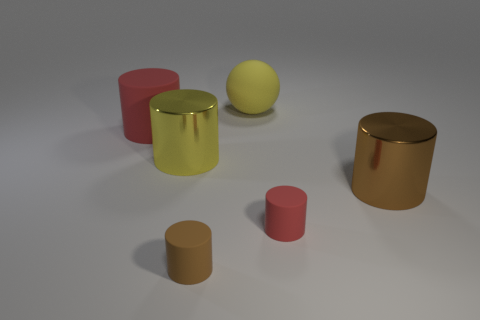Are there any other things that are the same shape as the large yellow rubber thing?
Give a very brief answer. No. There is a large cylinder on the left side of the big yellow thing that is in front of the large red rubber thing; what is its material?
Ensure brevity in your answer.  Rubber. How many other matte things are the same shape as the brown rubber object?
Provide a succinct answer. 2. Is there a big cylinder of the same color as the ball?
Give a very brief answer. Yes. What number of things are either metal cylinders behind the large brown cylinder or yellow things right of the small brown cylinder?
Offer a terse response. 2. Are there any yellow matte spheres that are in front of the matte cylinder that is on the left side of the brown rubber cylinder?
Make the answer very short. No. What shape is the red thing that is the same size as the yellow metallic cylinder?
Your response must be concise. Cylinder. What number of things are small things behind the small brown thing or small red cylinders?
Offer a terse response. 1. What number of other objects are there of the same material as the tiny red cylinder?
Ensure brevity in your answer.  3. What is the shape of the object that is the same color as the big matte cylinder?
Provide a short and direct response. Cylinder. 